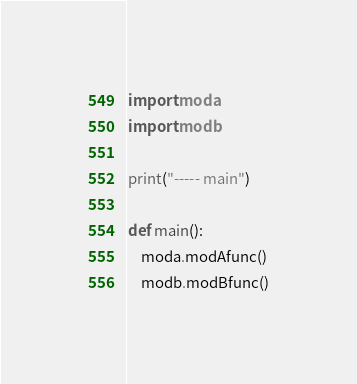Convert code to text. <code><loc_0><loc_0><loc_500><loc_500><_Python_>import moda
import modb

print("----- main")

def main():
    moda.modAfunc()
    modb.modBfunc()
</code> 